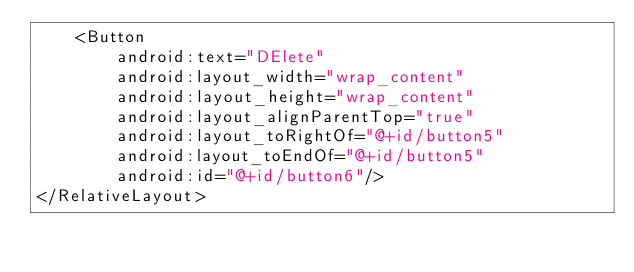Convert code to text. <code><loc_0><loc_0><loc_500><loc_500><_XML_>    <Button
        android:text="DElete"
        android:layout_width="wrap_content"
        android:layout_height="wrap_content"
        android:layout_alignParentTop="true"
        android:layout_toRightOf="@+id/button5"
        android:layout_toEndOf="@+id/button5"
        android:id="@+id/button6"/>
</RelativeLayout>
</code> 